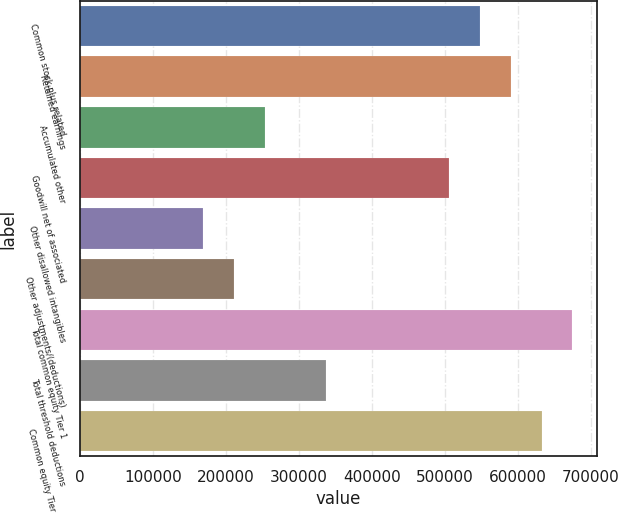Convert chart to OTSL. <chart><loc_0><loc_0><loc_500><loc_500><bar_chart><fcel>Common stock plus related<fcel>Retained earnings<fcel>Accumulated other<fcel>Goodwill net of associated<fcel>Other disallowed intangibles<fcel>Other adjustments/(deductions)<fcel>Total common equity Tier 1<fcel>Total threshold deductions<fcel>Common equity Tier 1 capital<nl><fcel>548250<fcel>590422<fcel>253042<fcel>506077<fcel>168696<fcel>210869<fcel>674768<fcel>337387<fcel>632595<nl></chart> 